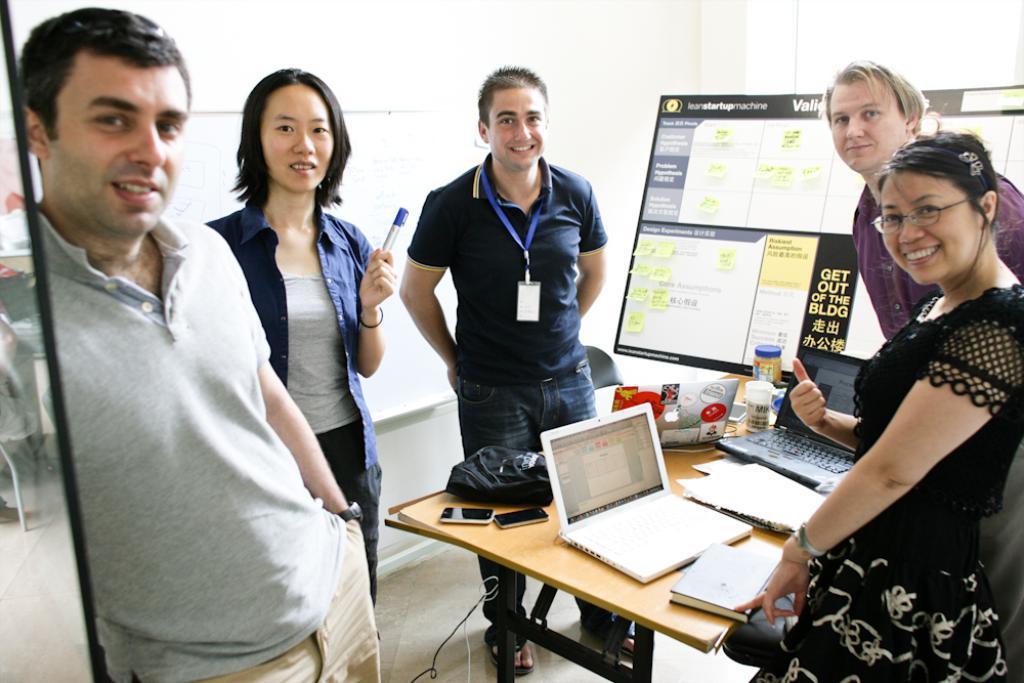Please provide a concise description of this image. In this image we can see a five persons. On the table there is a laptop,mobile,bag,bottle. 